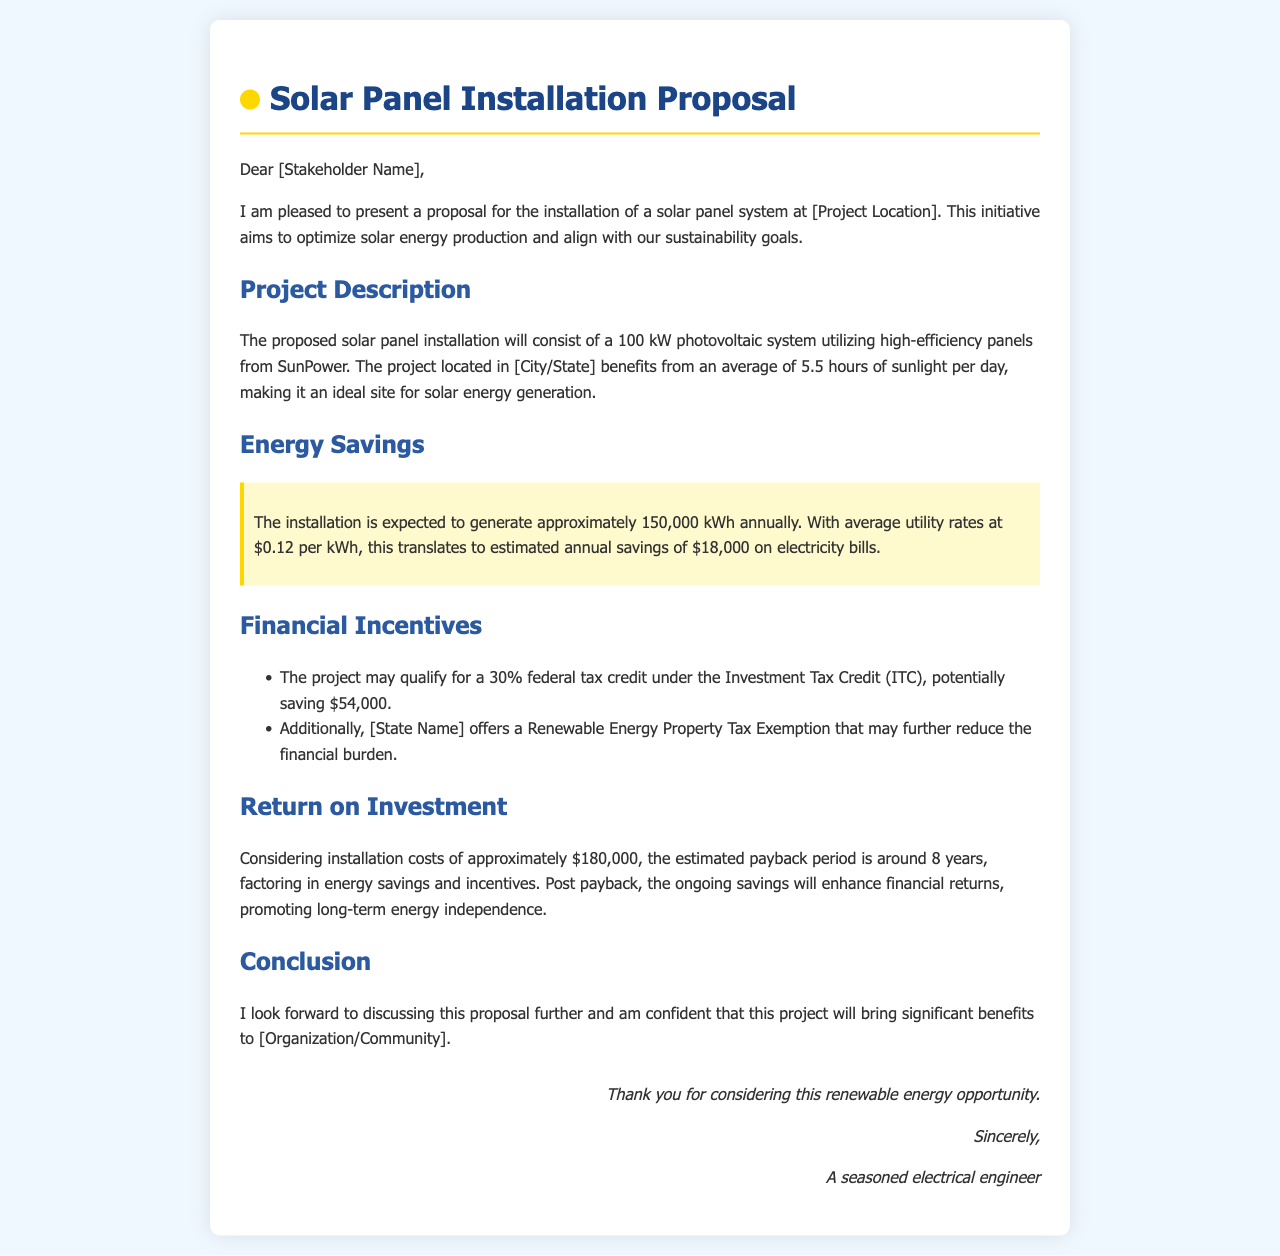What is the size of the solar panel system proposed? The proposal states that the solar panel system will consist of a 100 kW photovoltaic system.
Answer: 100 kW How much energy savings is expected annually? The document mentions that the installation is expected to generate approximately 150,000 kWh annually.
Answer: 150,000 kWh What is the estimated annual savings on electricity bills? The proposal indicates that this translates to estimated annual savings of $18,000 on electricity bills.
Answer: $18,000 What is the federal tax credit percentage available under ITC? The document states that the project may qualify for a 30% federal tax credit under the Investment Tax Credit (ITC).
Answer: 30% What is the installation cost mentioned in the proposal? The proposal provides installation costs of approximately $180,000.
Answer: $180,000 How long is the estimated payback period? The document mentions that the estimated payback period is around 8 years.
Answer: 8 years What is the average utility rate per kWh in the proposal? The proposal indicates that average utility rates are at $0.12 per kWh.
Answer: $0.12 Which state offers a Renewable Energy Property Tax Exemption? The proposal highlights that [State Name] offers a Renewable Energy Property Tax Exemption.
Answer: [State Name] What tone does the closing statement of the letter convey? The conclusion expresses confidence in the project's benefits and invites further discussion.
Answer: Confidence 